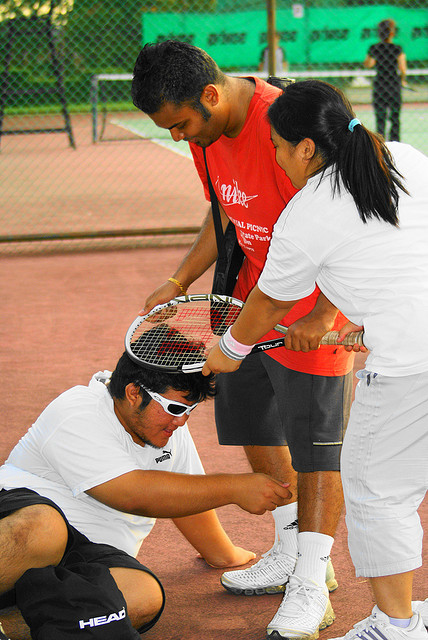What is happening on the tennis court? It appears to be a friendly interaction on a tennis court. A man is kneeling down while a woman adjusts his knee brace, and another man watches them, possibly offering assistance or waiting for his turn to play. 